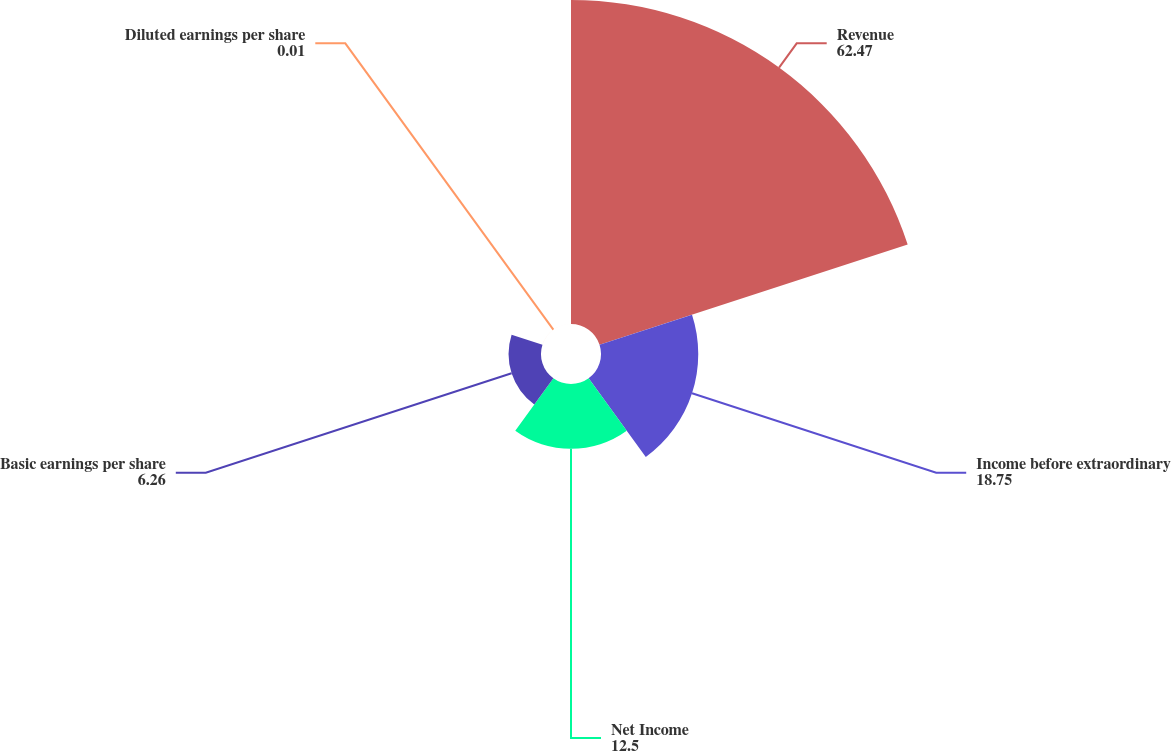<chart> <loc_0><loc_0><loc_500><loc_500><pie_chart><fcel>Revenue<fcel>Income before extraordinary<fcel>Net Income<fcel>Basic earnings per share<fcel>Diluted earnings per share<nl><fcel>62.47%<fcel>18.75%<fcel>12.5%<fcel>6.26%<fcel>0.01%<nl></chart> 